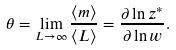Convert formula to latex. <formula><loc_0><loc_0><loc_500><loc_500>\theta = \lim _ { L \to \infty } \frac { \langle m \rangle } { \langle L \rangle } = \frac { \partial \ln z ^ { * } } { \partial \ln w } .</formula> 